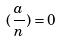Convert formula to latex. <formula><loc_0><loc_0><loc_500><loc_500>( \frac { a } { n } ) = 0</formula> 